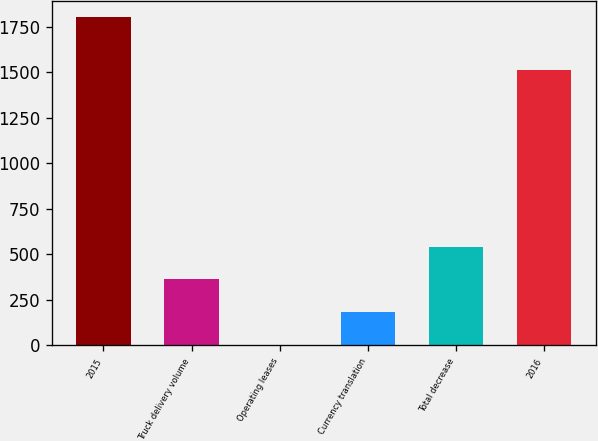<chart> <loc_0><loc_0><loc_500><loc_500><bar_chart><fcel>2015<fcel>Truck delivery volume<fcel>Operating leases<fcel>Currency translation<fcel>Total decrease<fcel>2016<nl><fcel>1804.2<fcel>361.88<fcel>1.3<fcel>181.59<fcel>542.17<fcel>1510.5<nl></chart> 